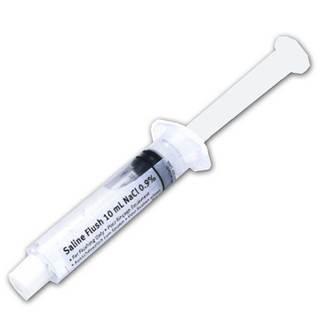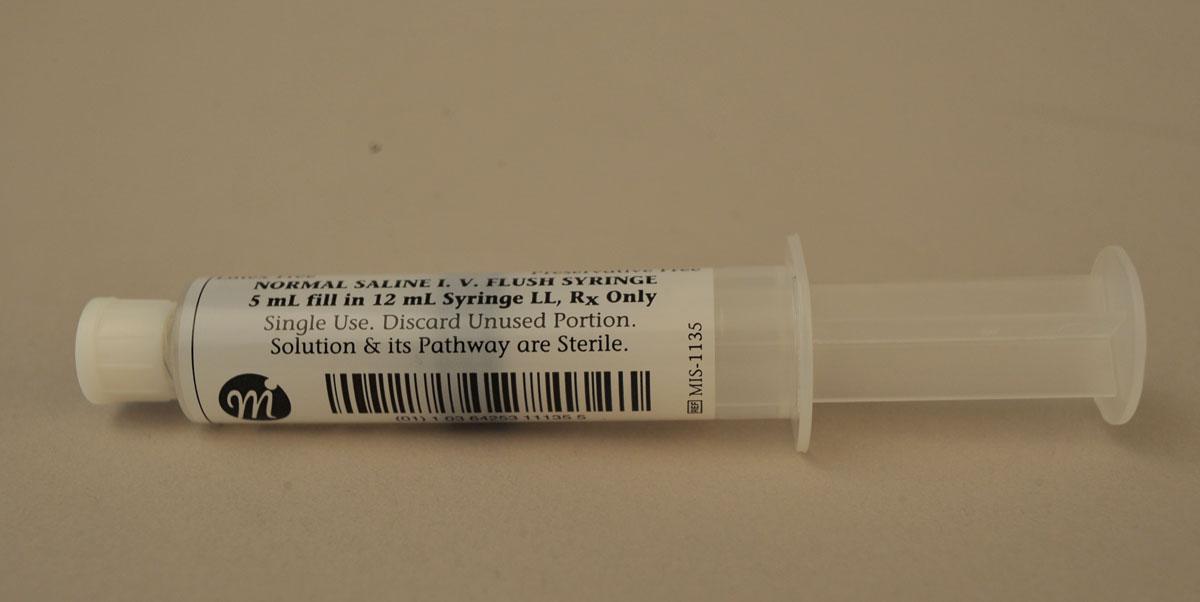The first image is the image on the left, the second image is the image on the right. Given the left and right images, does the statement "The right image shows a single syringe." hold true? Answer yes or no. Yes. 